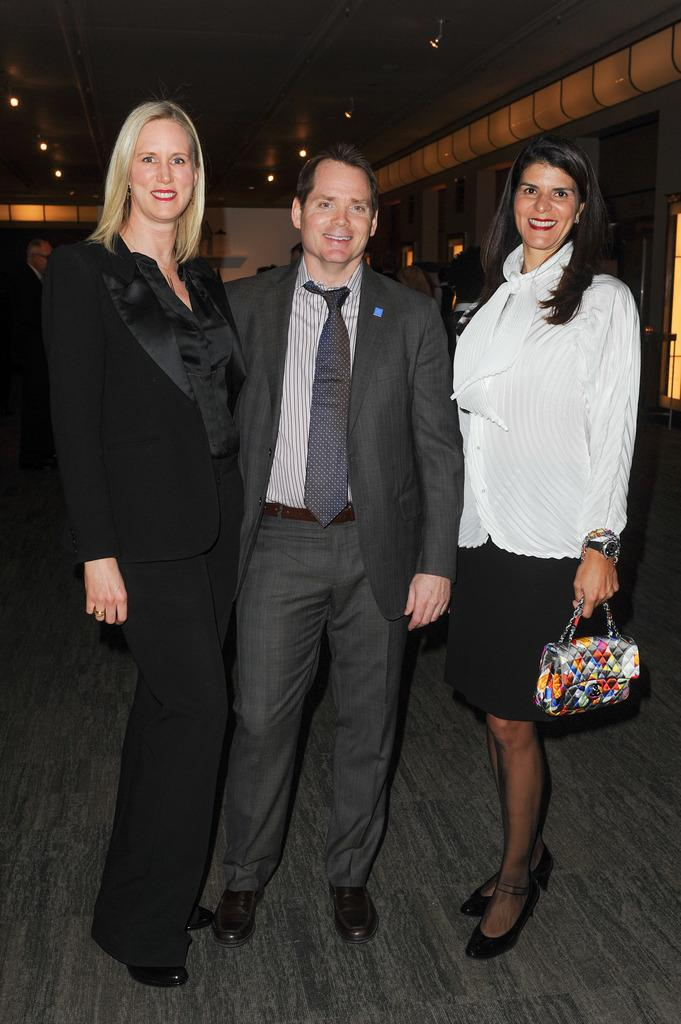How many people are standing next to the ladies in the image? There are two people standing next to the ladies in the image, one on the left side and one on the right side. Can you describe the position of the people in relation to the ladies? One person is standing on the left side of the ladies, and the other person is standing on the right side of the ladies. What type of bird can be seen perched on the wren in the image? There is no bird or wren present in the image. How many stitches are visible on the ring in the image? There is no ring or stitching present in the image. 